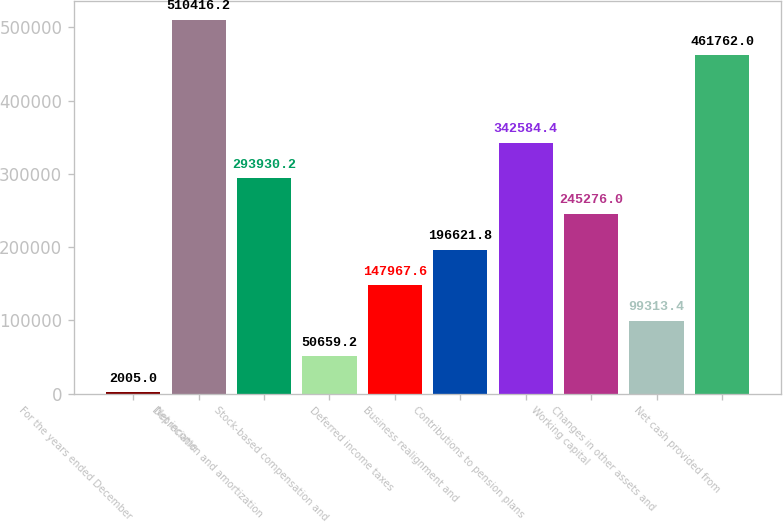Convert chart. <chart><loc_0><loc_0><loc_500><loc_500><bar_chart><fcel>For the years ended December<fcel>Net income<fcel>Depreciation and amortization<fcel>Stock-based compensation and<fcel>Deferred income taxes<fcel>Business realignment and<fcel>Contributions to pension plans<fcel>Working capital<fcel>Changes in other assets and<fcel>Net cash provided from<nl><fcel>2005<fcel>510416<fcel>293930<fcel>50659.2<fcel>147968<fcel>196622<fcel>342584<fcel>245276<fcel>99313.4<fcel>461762<nl></chart> 